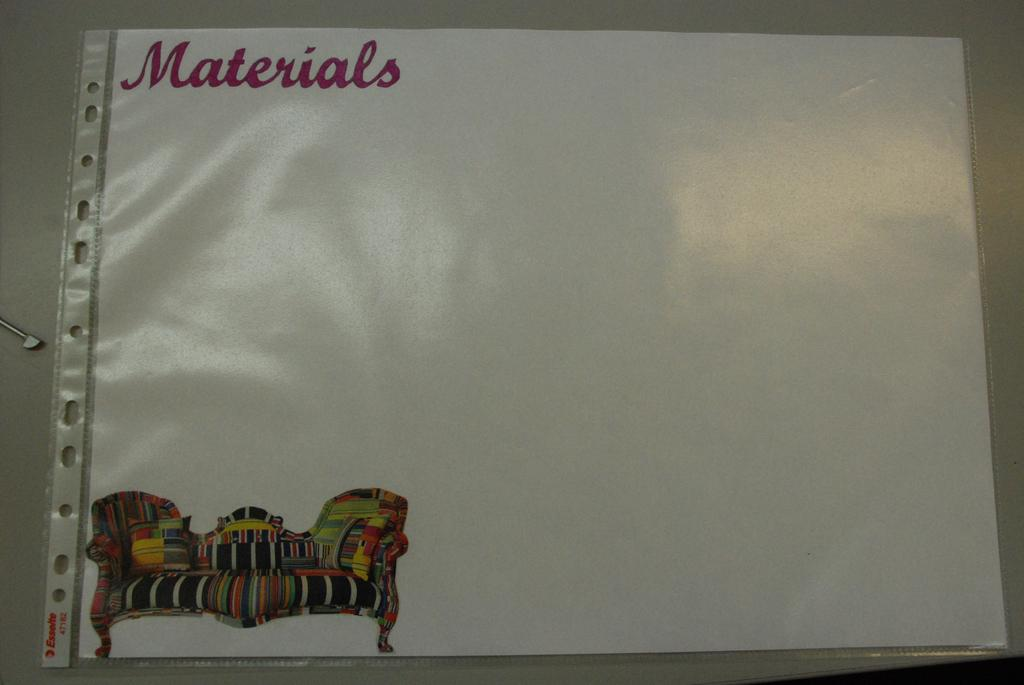<image>
Create a compact narrative representing the image presented. A sheet of paper with materials written above an image of an ornate sofa is in a plastic binder. 